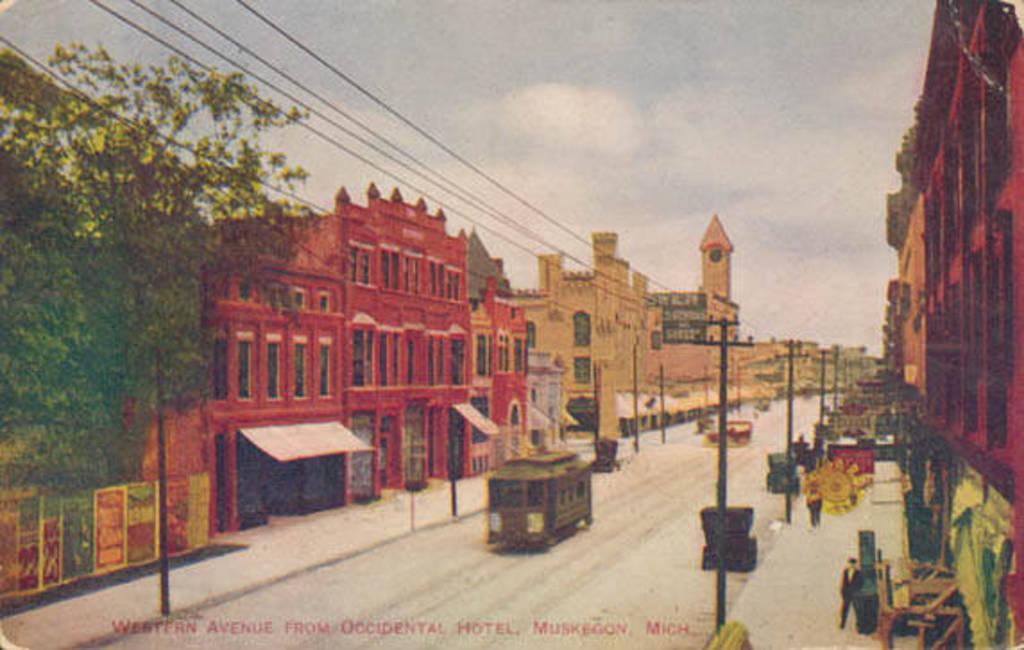How would you summarize this image in a sentence or two? In this image we can see a picture in which we can see a person standing on the ground. In the left side of the image we can see a tree. In the center of the image we can see a chart and some poles. In the background, we can see a group of buildings with windows. At the top of the image we can see some cables and the sky. At the bottom of the image we can see some text. 